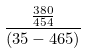<formula> <loc_0><loc_0><loc_500><loc_500>\frac { \frac { 3 8 0 } { 4 5 4 } } { ( 3 5 - 4 6 5 ) }</formula> 